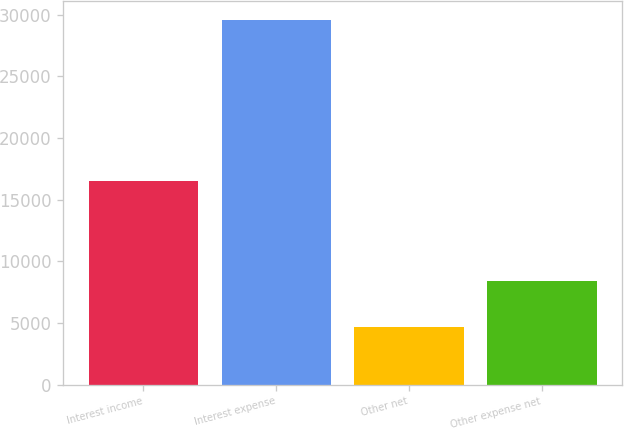Convert chart. <chart><loc_0><loc_0><loc_500><loc_500><bar_chart><fcel>Interest income<fcel>Interest expense<fcel>Other net<fcel>Other expense net<nl><fcel>16531<fcel>29607<fcel>4646<fcel>8430<nl></chart> 